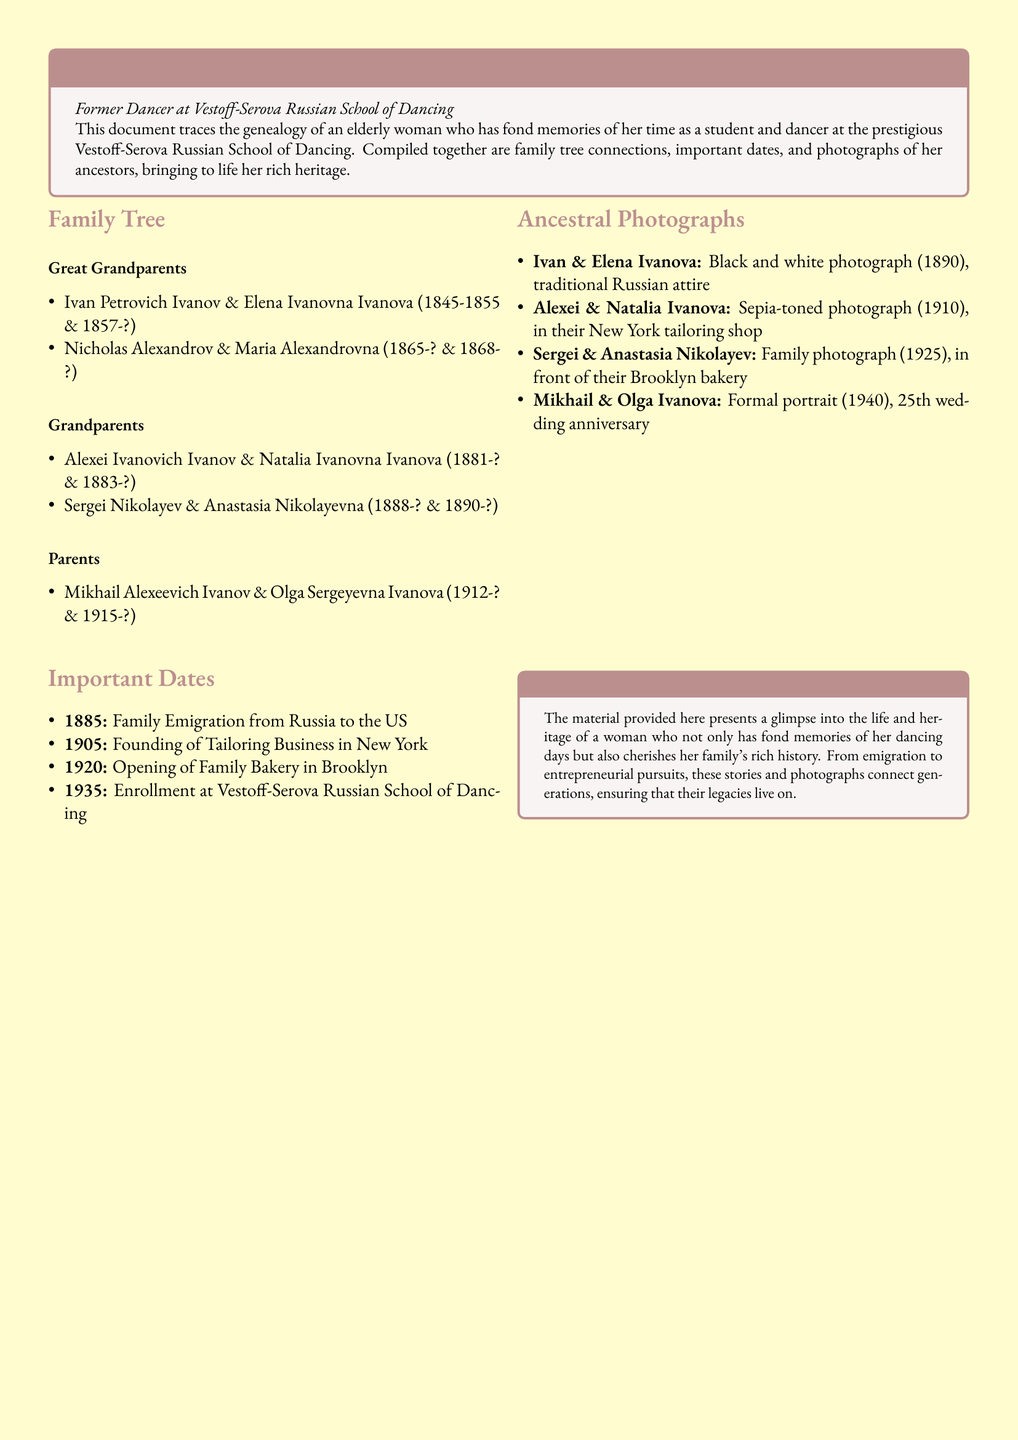what is the name of the great grandmother? The document lists Elena Ivanovna Ivanova as the great grandmother.
Answer: Elena Ivanovna Ivanova what year did the family emigrate from Russia? The document states that the family emigrated in 1885.
Answer: 1885 who opened a bakery in Brooklyn? The document mentions Sergei and Anastasia Nikolayev opened a bakery in Brooklyn.
Answer: Sergei and Anastasia Nikolayev how many generations are included in the family tree? The family tree contains four generations: great grandparents, grandparents, parents, and the individual herself.
Answer: Four generations what type of photograph is associated with Ivan and Elena Ivanova? The document specifies that there is a black and white photograph of Ivan and Elena Ivanova.
Answer: Black and white photograph what business was founded in 1905? The document indicates the founding of a tailoring business in New York in 1905.
Answer: Tailoring Business which ancestor's photograph features traditional attire? The photograph of Ivan and Elena Ivanova features traditional Russian attire.
Answer: Ivan and Elena Ivanova what significant event happened in 1935? The document notes the enrollment at the Vestoff-Serova Russian School of Dancing in 1935.
Answer: Enrollment at the Vestoff-Serova Russian School of Dancing 